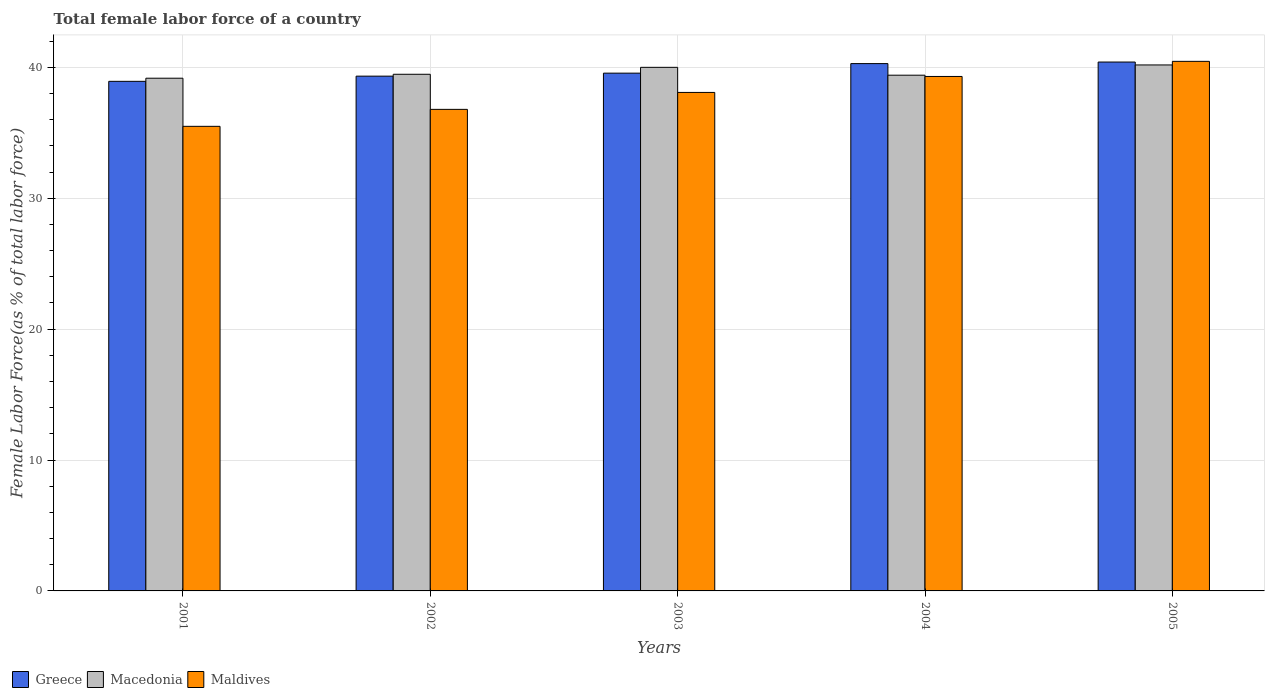How many bars are there on the 3rd tick from the left?
Your response must be concise. 3. How many bars are there on the 1st tick from the right?
Make the answer very short. 3. What is the label of the 4th group of bars from the left?
Your answer should be compact. 2004. What is the percentage of female labor force in Maldives in 2001?
Your answer should be very brief. 35.49. Across all years, what is the maximum percentage of female labor force in Greece?
Your answer should be very brief. 40.41. Across all years, what is the minimum percentage of female labor force in Maldives?
Give a very brief answer. 35.49. What is the total percentage of female labor force in Maldives in the graph?
Ensure brevity in your answer.  190.13. What is the difference between the percentage of female labor force in Macedonia in 2001 and that in 2002?
Your answer should be compact. -0.3. What is the difference between the percentage of female labor force in Macedonia in 2005 and the percentage of female labor force in Greece in 2004?
Give a very brief answer. -0.1. What is the average percentage of female labor force in Maldives per year?
Offer a terse response. 38.03. In the year 2001, what is the difference between the percentage of female labor force in Maldives and percentage of female labor force in Greece?
Give a very brief answer. -3.44. What is the ratio of the percentage of female labor force in Greece in 2001 to that in 2003?
Provide a succinct answer. 0.98. What is the difference between the highest and the second highest percentage of female labor force in Macedonia?
Provide a short and direct response. 0.18. What is the difference between the highest and the lowest percentage of female labor force in Greece?
Give a very brief answer. 1.47. What does the 2nd bar from the left in 2001 represents?
Your response must be concise. Macedonia. What does the 2nd bar from the right in 2003 represents?
Your response must be concise. Macedonia. Is it the case that in every year, the sum of the percentage of female labor force in Greece and percentage of female labor force in Macedonia is greater than the percentage of female labor force in Maldives?
Your answer should be very brief. Yes. How many bars are there?
Keep it short and to the point. 15. How many years are there in the graph?
Your answer should be very brief. 5. Are the values on the major ticks of Y-axis written in scientific E-notation?
Provide a succinct answer. No. Does the graph contain any zero values?
Make the answer very short. No. Does the graph contain grids?
Keep it short and to the point. Yes. How many legend labels are there?
Give a very brief answer. 3. What is the title of the graph?
Ensure brevity in your answer.  Total female labor force of a country. Does "South Sudan" appear as one of the legend labels in the graph?
Provide a succinct answer. No. What is the label or title of the X-axis?
Your answer should be compact. Years. What is the label or title of the Y-axis?
Keep it short and to the point. Female Labor Force(as % of total labor force). What is the Female Labor Force(as % of total labor force) in Greece in 2001?
Provide a short and direct response. 38.93. What is the Female Labor Force(as % of total labor force) of Macedonia in 2001?
Your answer should be very brief. 39.17. What is the Female Labor Force(as % of total labor force) of Maldives in 2001?
Ensure brevity in your answer.  35.49. What is the Female Labor Force(as % of total labor force) in Greece in 2002?
Make the answer very short. 39.33. What is the Female Labor Force(as % of total labor force) of Macedonia in 2002?
Your answer should be compact. 39.47. What is the Female Labor Force(as % of total labor force) of Maldives in 2002?
Your answer should be very brief. 36.79. What is the Female Labor Force(as % of total labor force) in Greece in 2003?
Make the answer very short. 39.56. What is the Female Labor Force(as % of total labor force) of Macedonia in 2003?
Give a very brief answer. 40. What is the Female Labor Force(as % of total labor force) in Maldives in 2003?
Your answer should be compact. 38.08. What is the Female Labor Force(as % of total labor force) of Greece in 2004?
Offer a very short reply. 40.29. What is the Female Labor Force(as % of total labor force) of Macedonia in 2004?
Your answer should be very brief. 39.4. What is the Female Labor Force(as % of total labor force) of Maldives in 2004?
Make the answer very short. 39.3. What is the Female Labor Force(as % of total labor force) of Greece in 2005?
Keep it short and to the point. 40.41. What is the Female Labor Force(as % of total labor force) of Macedonia in 2005?
Provide a short and direct response. 40.18. What is the Female Labor Force(as % of total labor force) of Maldives in 2005?
Your answer should be very brief. 40.46. Across all years, what is the maximum Female Labor Force(as % of total labor force) in Greece?
Your answer should be compact. 40.41. Across all years, what is the maximum Female Labor Force(as % of total labor force) of Macedonia?
Offer a very short reply. 40.18. Across all years, what is the maximum Female Labor Force(as % of total labor force) in Maldives?
Provide a short and direct response. 40.46. Across all years, what is the minimum Female Labor Force(as % of total labor force) in Greece?
Make the answer very short. 38.93. Across all years, what is the minimum Female Labor Force(as % of total labor force) in Macedonia?
Ensure brevity in your answer.  39.17. Across all years, what is the minimum Female Labor Force(as % of total labor force) in Maldives?
Provide a succinct answer. 35.49. What is the total Female Labor Force(as % of total labor force) in Greece in the graph?
Keep it short and to the point. 198.51. What is the total Female Labor Force(as % of total labor force) of Macedonia in the graph?
Offer a terse response. 198.23. What is the total Female Labor Force(as % of total labor force) of Maldives in the graph?
Make the answer very short. 190.13. What is the difference between the Female Labor Force(as % of total labor force) of Greece in 2001 and that in 2002?
Offer a very short reply. -0.4. What is the difference between the Female Labor Force(as % of total labor force) of Macedonia in 2001 and that in 2002?
Your response must be concise. -0.3. What is the difference between the Female Labor Force(as % of total labor force) of Maldives in 2001 and that in 2002?
Provide a short and direct response. -1.3. What is the difference between the Female Labor Force(as % of total labor force) in Greece in 2001 and that in 2003?
Keep it short and to the point. -0.63. What is the difference between the Female Labor Force(as % of total labor force) in Macedonia in 2001 and that in 2003?
Make the answer very short. -0.83. What is the difference between the Female Labor Force(as % of total labor force) in Maldives in 2001 and that in 2003?
Give a very brief answer. -2.59. What is the difference between the Female Labor Force(as % of total labor force) in Greece in 2001 and that in 2004?
Offer a terse response. -1.35. What is the difference between the Female Labor Force(as % of total labor force) of Macedonia in 2001 and that in 2004?
Your answer should be very brief. -0.23. What is the difference between the Female Labor Force(as % of total labor force) in Maldives in 2001 and that in 2004?
Give a very brief answer. -3.81. What is the difference between the Female Labor Force(as % of total labor force) in Greece in 2001 and that in 2005?
Your response must be concise. -1.47. What is the difference between the Female Labor Force(as % of total labor force) of Macedonia in 2001 and that in 2005?
Your response must be concise. -1.01. What is the difference between the Female Labor Force(as % of total labor force) in Maldives in 2001 and that in 2005?
Offer a very short reply. -4.97. What is the difference between the Female Labor Force(as % of total labor force) in Greece in 2002 and that in 2003?
Your answer should be compact. -0.23. What is the difference between the Female Labor Force(as % of total labor force) of Macedonia in 2002 and that in 2003?
Ensure brevity in your answer.  -0.53. What is the difference between the Female Labor Force(as % of total labor force) of Maldives in 2002 and that in 2003?
Give a very brief answer. -1.29. What is the difference between the Female Labor Force(as % of total labor force) of Greece in 2002 and that in 2004?
Keep it short and to the point. -0.96. What is the difference between the Female Labor Force(as % of total labor force) in Macedonia in 2002 and that in 2004?
Offer a very short reply. 0.07. What is the difference between the Female Labor Force(as % of total labor force) in Maldives in 2002 and that in 2004?
Your response must be concise. -2.51. What is the difference between the Female Labor Force(as % of total labor force) in Greece in 2002 and that in 2005?
Ensure brevity in your answer.  -1.08. What is the difference between the Female Labor Force(as % of total labor force) of Macedonia in 2002 and that in 2005?
Provide a succinct answer. -0.71. What is the difference between the Female Labor Force(as % of total labor force) of Maldives in 2002 and that in 2005?
Give a very brief answer. -3.67. What is the difference between the Female Labor Force(as % of total labor force) in Greece in 2003 and that in 2004?
Make the answer very short. -0.73. What is the difference between the Female Labor Force(as % of total labor force) in Macedonia in 2003 and that in 2004?
Your answer should be compact. 0.6. What is the difference between the Female Labor Force(as % of total labor force) in Maldives in 2003 and that in 2004?
Offer a very short reply. -1.22. What is the difference between the Female Labor Force(as % of total labor force) in Greece in 2003 and that in 2005?
Your response must be concise. -0.85. What is the difference between the Female Labor Force(as % of total labor force) of Macedonia in 2003 and that in 2005?
Provide a short and direct response. -0.18. What is the difference between the Female Labor Force(as % of total labor force) of Maldives in 2003 and that in 2005?
Provide a short and direct response. -2.37. What is the difference between the Female Labor Force(as % of total labor force) of Greece in 2004 and that in 2005?
Provide a short and direct response. -0.12. What is the difference between the Female Labor Force(as % of total labor force) in Macedonia in 2004 and that in 2005?
Offer a terse response. -0.78. What is the difference between the Female Labor Force(as % of total labor force) of Maldives in 2004 and that in 2005?
Provide a short and direct response. -1.15. What is the difference between the Female Labor Force(as % of total labor force) of Greece in 2001 and the Female Labor Force(as % of total labor force) of Macedonia in 2002?
Provide a short and direct response. -0.54. What is the difference between the Female Labor Force(as % of total labor force) of Greece in 2001 and the Female Labor Force(as % of total labor force) of Maldives in 2002?
Your answer should be very brief. 2.14. What is the difference between the Female Labor Force(as % of total labor force) in Macedonia in 2001 and the Female Labor Force(as % of total labor force) in Maldives in 2002?
Your answer should be compact. 2.38. What is the difference between the Female Labor Force(as % of total labor force) in Greece in 2001 and the Female Labor Force(as % of total labor force) in Macedonia in 2003?
Provide a short and direct response. -1.07. What is the difference between the Female Labor Force(as % of total labor force) in Greece in 2001 and the Female Labor Force(as % of total labor force) in Maldives in 2003?
Provide a succinct answer. 0.85. What is the difference between the Female Labor Force(as % of total labor force) of Macedonia in 2001 and the Female Labor Force(as % of total labor force) of Maldives in 2003?
Your response must be concise. 1.09. What is the difference between the Female Labor Force(as % of total labor force) in Greece in 2001 and the Female Labor Force(as % of total labor force) in Macedonia in 2004?
Provide a succinct answer. -0.47. What is the difference between the Female Labor Force(as % of total labor force) in Greece in 2001 and the Female Labor Force(as % of total labor force) in Maldives in 2004?
Give a very brief answer. -0.37. What is the difference between the Female Labor Force(as % of total labor force) of Macedonia in 2001 and the Female Labor Force(as % of total labor force) of Maldives in 2004?
Provide a succinct answer. -0.13. What is the difference between the Female Labor Force(as % of total labor force) in Greece in 2001 and the Female Labor Force(as % of total labor force) in Macedonia in 2005?
Keep it short and to the point. -1.25. What is the difference between the Female Labor Force(as % of total labor force) of Greece in 2001 and the Female Labor Force(as % of total labor force) of Maldives in 2005?
Offer a terse response. -1.53. What is the difference between the Female Labor Force(as % of total labor force) in Macedonia in 2001 and the Female Labor Force(as % of total labor force) in Maldives in 2005?
Your answer should be compact. -1.29. What is the difference between the Female Labor Force(as % of total labor force) of Greece in 2002 and the Female Labor Force(as % of total labor force) of Macedonia in 2003?
Provide a succinct answer. -0.67. What is the difference between the Female Labor Force(as % of total labor force) in Greece in 2002 and the Female Labor Force(as % of total labor force) in Maldives in 2003?
Give a very brief answer. 1.24. What is the difference between the Female Labor Force(as % of total labor force) in Macedonia in 2002 and the Female Labor Force(as % of total labor force) in Maldives in 2003?
Your answer should be compact. 1.39. What is the difference between the Female Labor Force(as % of total labor force) in Greece in 2002 and the Female Labor Force(as % of total labor force) in Macedonia in 2004?
Provide a succinct answer. -0.07. What is the difference between the Female Labor Force(as % of total labor force) of Greece in 2002 and the Female Labor Force(as % of total labor force) of Maldives in 2004?
Your answer should be very brief. 0.02. What is the difference between the Female Labor Force(as % of total labor force) of Macedonia in 2002 and the Female Labor Force(as % of total labor force) of Maldives in 2004?
Your answer should be very brief. 0.17. What is the difference between the Female Labor Force(as % of total labor force) in Greece in 2002 and the Female Labor Force(as % of total labor force) in Macedonia in 2005?
Provide a succinct answer. -0.86. What is the difference between the Female Labor Force(as % of total labor force) of Greece in 2002 and the Female Labor Force(as % of total labor force) of Maldives in 2005?
Offer a terse response. -1.13. What is the difference between the Female Labor Force(as % of total labor force) of Macedonia in 2002 and the Female Labor Force(as % of total labor force) of Maldives in 2005?
Make the answer very short. -0.99. What is the difference between the Female Labor Force(as % of total labor force) of Greece in 2003 and the Female Labor Force(as % of total labor force) of Macedonia in 2004?
Provide a succinct answer. 0.16. What is the difference between the Female Labor Force(as % of total labor force) in Greece in 2003 and the Female Labor Force(as % of total labor force) in Maldives in 2004?
Provide a short and direct response. 0.25. What is the difference between the Female Labor Force(as % of total labor force) of Macedonia in 2003 and the Female Labor Force(as % of total labor force) of Maldives in 2004?
Your answer should be very brief. 0.7. What is the difference between the Female Labor Force(as % of total labor force) of Greece in 2003 and the Female Labor Force(as % of total labor force) of Macedonia in 2005?
Make the answer very short. -0.63. What is the difference between the Female Labor Force(as % of total labor force) in Greece in 2003 and the Female Labor Force(as % of total labor force) in Maldives in 2005?
Provide a short and direct response. -0.9. What is the difference between the Female Labor Force(as % of total labor force) of Macedonia in 2003 and the Female Labor Force(as % of total labor force) of Maldives in 2005?
Keep it short and to the point. -0.46. What is the difference between the Female Labor Force(as % of total labor force) of Greece in 2004 and the Female Labor Force(as % of total labor force) of Macedonia in 2005?
Make the answer very short. 0.1. What is the difference between the Female Labor Force(as % of total labor force) in Greece in 2004 and the Female Labor Force(as % of total labor force) in Maldives in 2005?
Your answer should be compact. -0.17. What is the difference between the Female Labor Force(as % of total labor force) in Macedonia in 2004 and the Female Labor Force(as % of total labor force) in Maldives in 2005?
Provide a succinct answer. -1.06. What is the average Female Labor Force(as % of total labor force) of Greece per year?
Your answer should be compact. 39.7. What is the average Female Labor Force(as % of total labor force) in Macedonia per year?
Ensure brevity in your answer.  39.65. What is the average Female Labor Force(as % of total labor force) in Maldives per year?
Provide a short and direct response. 38.03. In the year 2001, what is the difference between the Female Labor Force(as % of total labor force) in Greece and Female Labor Force(as % of total labor force) in Macedonia?
Provide a short and direct response. -0.24. In the year 2001, what is the difference between the Female Labor Force(as % of total labor force) of Greece and Female Labor Force(as % of total labor force) of Maldives?
Offer a terse response. 3.44. In the year 2001, what is the difference between the Female Labor Force(as % of total labor force) of Macedonia and Female Labor Force(as % of total labor force) of Maldives?
Offer a very short reply. 3.68. In the year 2002, what is the difference between the Female Labor Force(as % of total labor force) of Greece and Female Labor Force(as % of total labor force) of Macedonia?
Your answer should be very brief. -0.14. In the year 2002, what is the difference between the Female Labor Force(as % of total labor force) in Greece and Female Labor Force(as % of total labor force) in Maldives?
Offer a very short reply. 2.54. In the year 2002, what is the difference between the Female Labor Force(as % of total labor force) of Macedonia and Female Labor Force(as % of total labor force) of Maldives?
Provide a succinct answer. 2.68. In the year 2003, what is the difference between the Female Labor Force(as % of total labor force) of Greece and Female Labor Force(as % of total labor force) of Macedonia?
Offer a terse response. -0.44. In the year 2003, what is the difference between the Female Labor Force(as % of total labor force) of Greece and Female Labor Force(as % of total labor force) of Maldives?
Offer a terse response. 1.47. In the year 2003, what is the difference between the Female Labor Force(as % of total labor force) of Macedonia and Female Labor Force(as % of total labor force) of Maldives?
Provide a succinct answer. 1.92. In the year 2004, what is the difference between the Female Labor Force(as % of total labor force) of Greece and Female Labor Force(as % of total labor force) of Macedonia?
Provide a succinct answer. 0.89. In the year 2004, what is the difference between the Female Labor Force(as % of total labor force) in Greece and Female Labor Force(as % of total labor force) in Maldives?
Provide a short and direct response. 0.98. In the year 2004, what is the difference between the Female Labor Force(as % of total labor force) in Macedonia and Female Labor Force(as % of total labor force) in Maldives?
Provide a succinct answer. 0.1. In the year 2005, what is the difference between the Female Labor Force(as % of total labor force) of Greece and Female Labor Force(as % of total labor force) of Macedonia?
Make the answer very short. 0.22. In the year 2005, what is the difference between the Female Labor Force(as % of total labor force) of Greece and Female Labor Force(as % of total labor force) of Maldives?
Your response must be concise. -0.05. In the year 2005, what is the difference between the Female Labor Force(as % of total labor force) in Macedonia and Female Labor Force(as % of total labor force) in Maldives?
Provide a short and direct response. -0.27. What is the ratio of the Female Labor Force(as % of total labor force) in Greece in 2001 to that in 2002?
Offer a very short reply. 0.99. What is the ratio of the Female Labor Force(as % of total labor force) of Maldives in 2001 to that in 2002?
Keep it short and to the point. 0.96. What is the ratio of the Female Labor Force(as % of total labor force) in Greece in 2001 to that in 2003?
Ensure brevity in your answer.  0.98. What is the ratio of the Female Labor Force(as % of total labor force) in Macedonia in 2001 to that in 2003?
Your answer should be compact. 0.98. What is the ratio of the Female Labor Force(as % of total labor force) in Maldives in 2001 to that in 2003?
Offer a very short reply. 0.93. What is the ratio of the Female Labor Force(as % of total labor force) of Greece in 2001 to that in 2004?
Your answer should be very brief. 0.97. What is the ratio of the Female Labor Force(as % of total labor force) of Macedonia in 2001 to that in 2004?
Your answer should be very brief. 0.99. What is the ratio of the Female Labor Force(as % of total labor force) of Maldives in 2001 to that in 2004?
Keep it short and to the point. 0.9. What is the ratio of the Female Labor Force(as % of total labor force) of Greece in 2001 to that in 2005?
Provide a succinct answer. 0.96. What is the ratio of the Female Labor Force(as % of total labor force) of Macedonia in 2001 to that in 2005?
Keep it short and to the point. 0.97. What is the ratio of the Female Labor Force(as % of total labor force) in Maldives in 2001 to that in 2005?
Your response must be concise. 0.88. What is the ratio of the Female Labor Force(as % of total labor force) in Macedonia in 2002 to that in 2003?
Keep it short and to the point. 0.99. What is the ratio of the Female Labor Force(as % of total labor force) of Greece in 2002 to that in 2004?
Make the answer very short. 0.98. What is the ratio of the Female Labor Force(as % of total labor force) of Maldives in 2002 to that in 2004?
Offer a terse response. 0.94. What is the ratio of the Female Labor Force(as % of total labor force) of Greece in 2002 to that in 2005?
Provide a succinct answer. 0.97. What is the ratio of the Female Labor Force(as % of total labor force) of Macedonia in 2002 to that in 2005?
Keep it short and to the point. 0.98. What is the ratio of the Female Labor Force(as % of total labor force) of Maldives in 2002 to that in 2005?
Provide a succinct answer. 0.91. What is the ratio of the Female Labor Force(as % of total labor force) of Greece in 2003 to that in 2004?
Your response must be concise. 0.98. What is the ratio of the Female Labor Force(as % of total labor force) in Macedonia in 2003 to that in 2004?
Offer a terse response. 1.02. What is the ratio of the Female Labor Force(as % of total labor force) of Maldives in 2003 to that in 2004?
Offer a very short reply. 0.97. What is the ratio of the Female Labor Force(as % of total labor force) in Greece in 2003 to that in 2005?
Offer a terse response. 0.98. What is the ratio of the Female Labor Force(as % of total labor force) in Macedonia in 2003 to that in 2005?
Ensure brevity in your answer.  1. What is the ratio of the Female Labor Force(as % of total labor force) of Maldives in 2003 to that in 2005?
Provide a succinct answer. 0.94. What is the ratio of the Female Labor Force(as % of total labor force) of Macedonia in 2004 to that in 2005?
Ensure brevity in your answer.  0.98. What is the ratio of the Female Labor Force(as % of total labor force) in Maldives in 2004 to that in 2005?
Provide a short and direct response. 0.97. What is the difference between the highest and the second highest Female Labor Force(as % of total labor force) in Greece?
Your response must be concise. 0.12. What is the difference between the highest and the second highest Female Labor Force(as % of total labor force) in Macedonia?
Your answer should be very brief. 0.18. What is the difference between the highest and the second highest Female Labor Force(as % of total labor force) of Maldives?
Ensure brevity in your answer.  1.15. What is the difference between the highest and the lowest Female Labor Force(as % of total labor force) in Greece?
Offer a terse response. 1.47. What is the difference between the highest and the lowest Female Labor Force(as % of total labor force) in Macedonia?
Make the answer very short. 1.01. What is the difference between the highest and the lowest Female Labor Force(as % of total labor force) of Maldives?
Your answer should be compact. 4.97. 